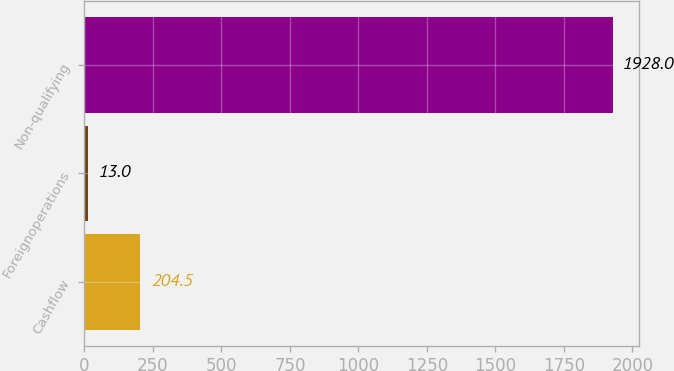Convert chart to OTSL. <chart><loc_0><loc_0><loc_500><loc_500><bar_chart><fcel>Cashflow<fcel>Foreignoperations<fcel>Non-qualifying<nl><fcel>204.5<fcel>13<fcel>1928<nl></chart> 